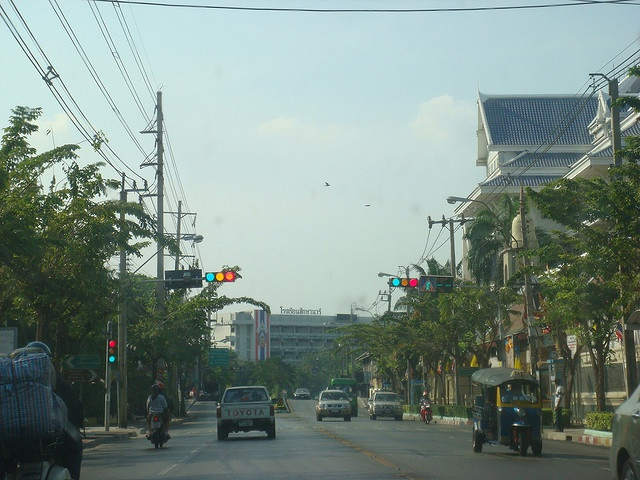Describe the objects in this image and their specific colors. I can see backpack in lightblue, black, darkblue, blue, and gray tones, truck in lightblue, black, purple, teal, and darkblue tones, car in lightblue, gray, black, darkgray, and darkgreen tones, car in lightblue, gray, black, purple, and darkgray tones, and car in lightblue, gray, and black tones in this image. 